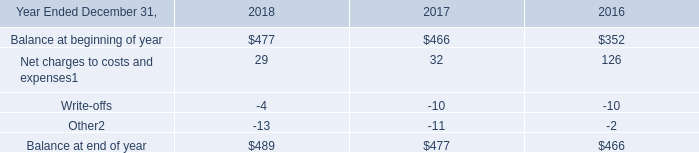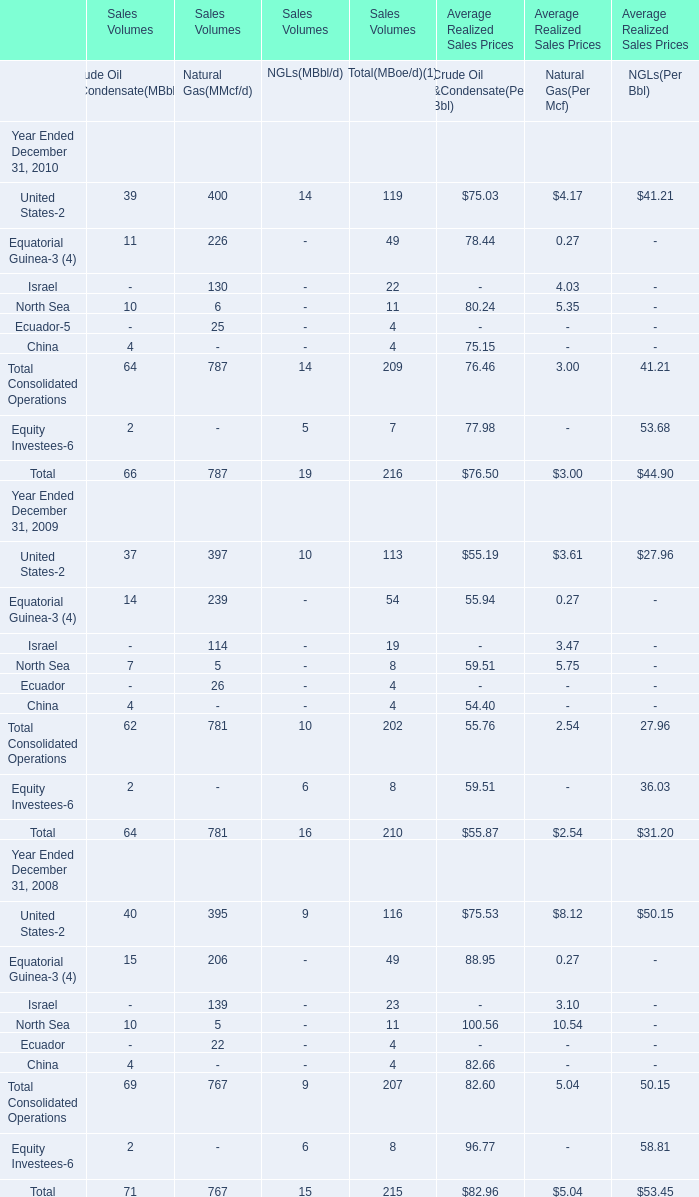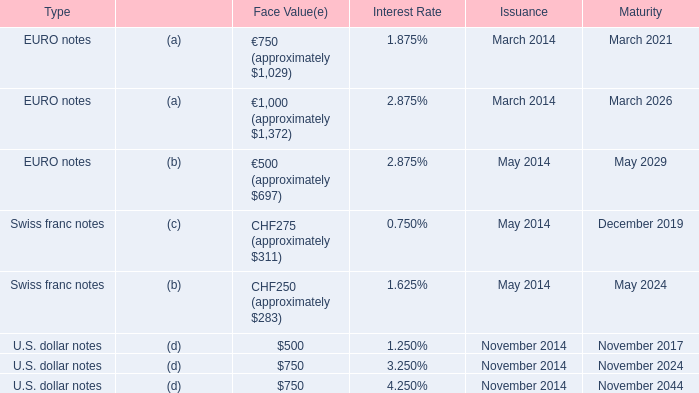What's the sum of all NGLs(MBbl/d) that are greater than 0 in 2009? 
Computations: (10 + 6)
Answer: 16.0. 